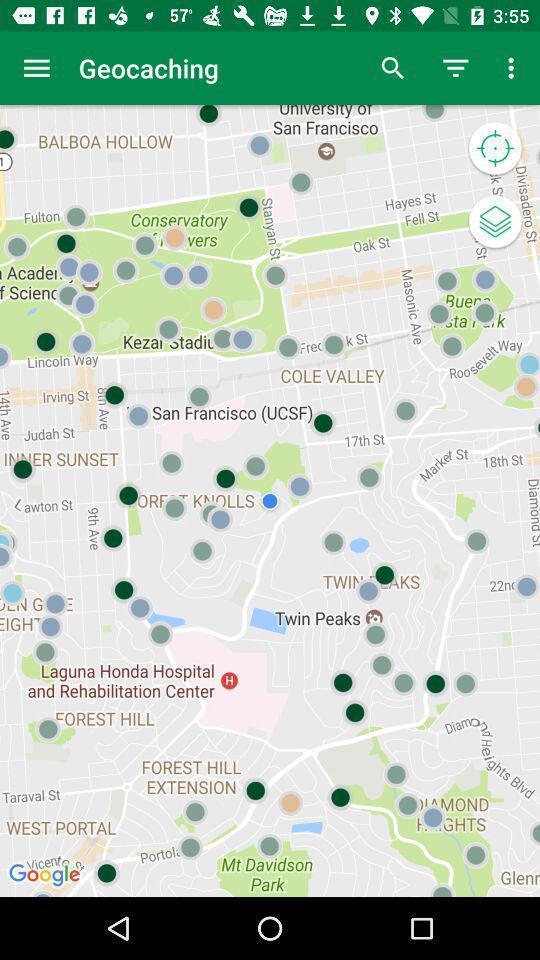What details can you identify in this image? Screen shows map view in a navigation app. 